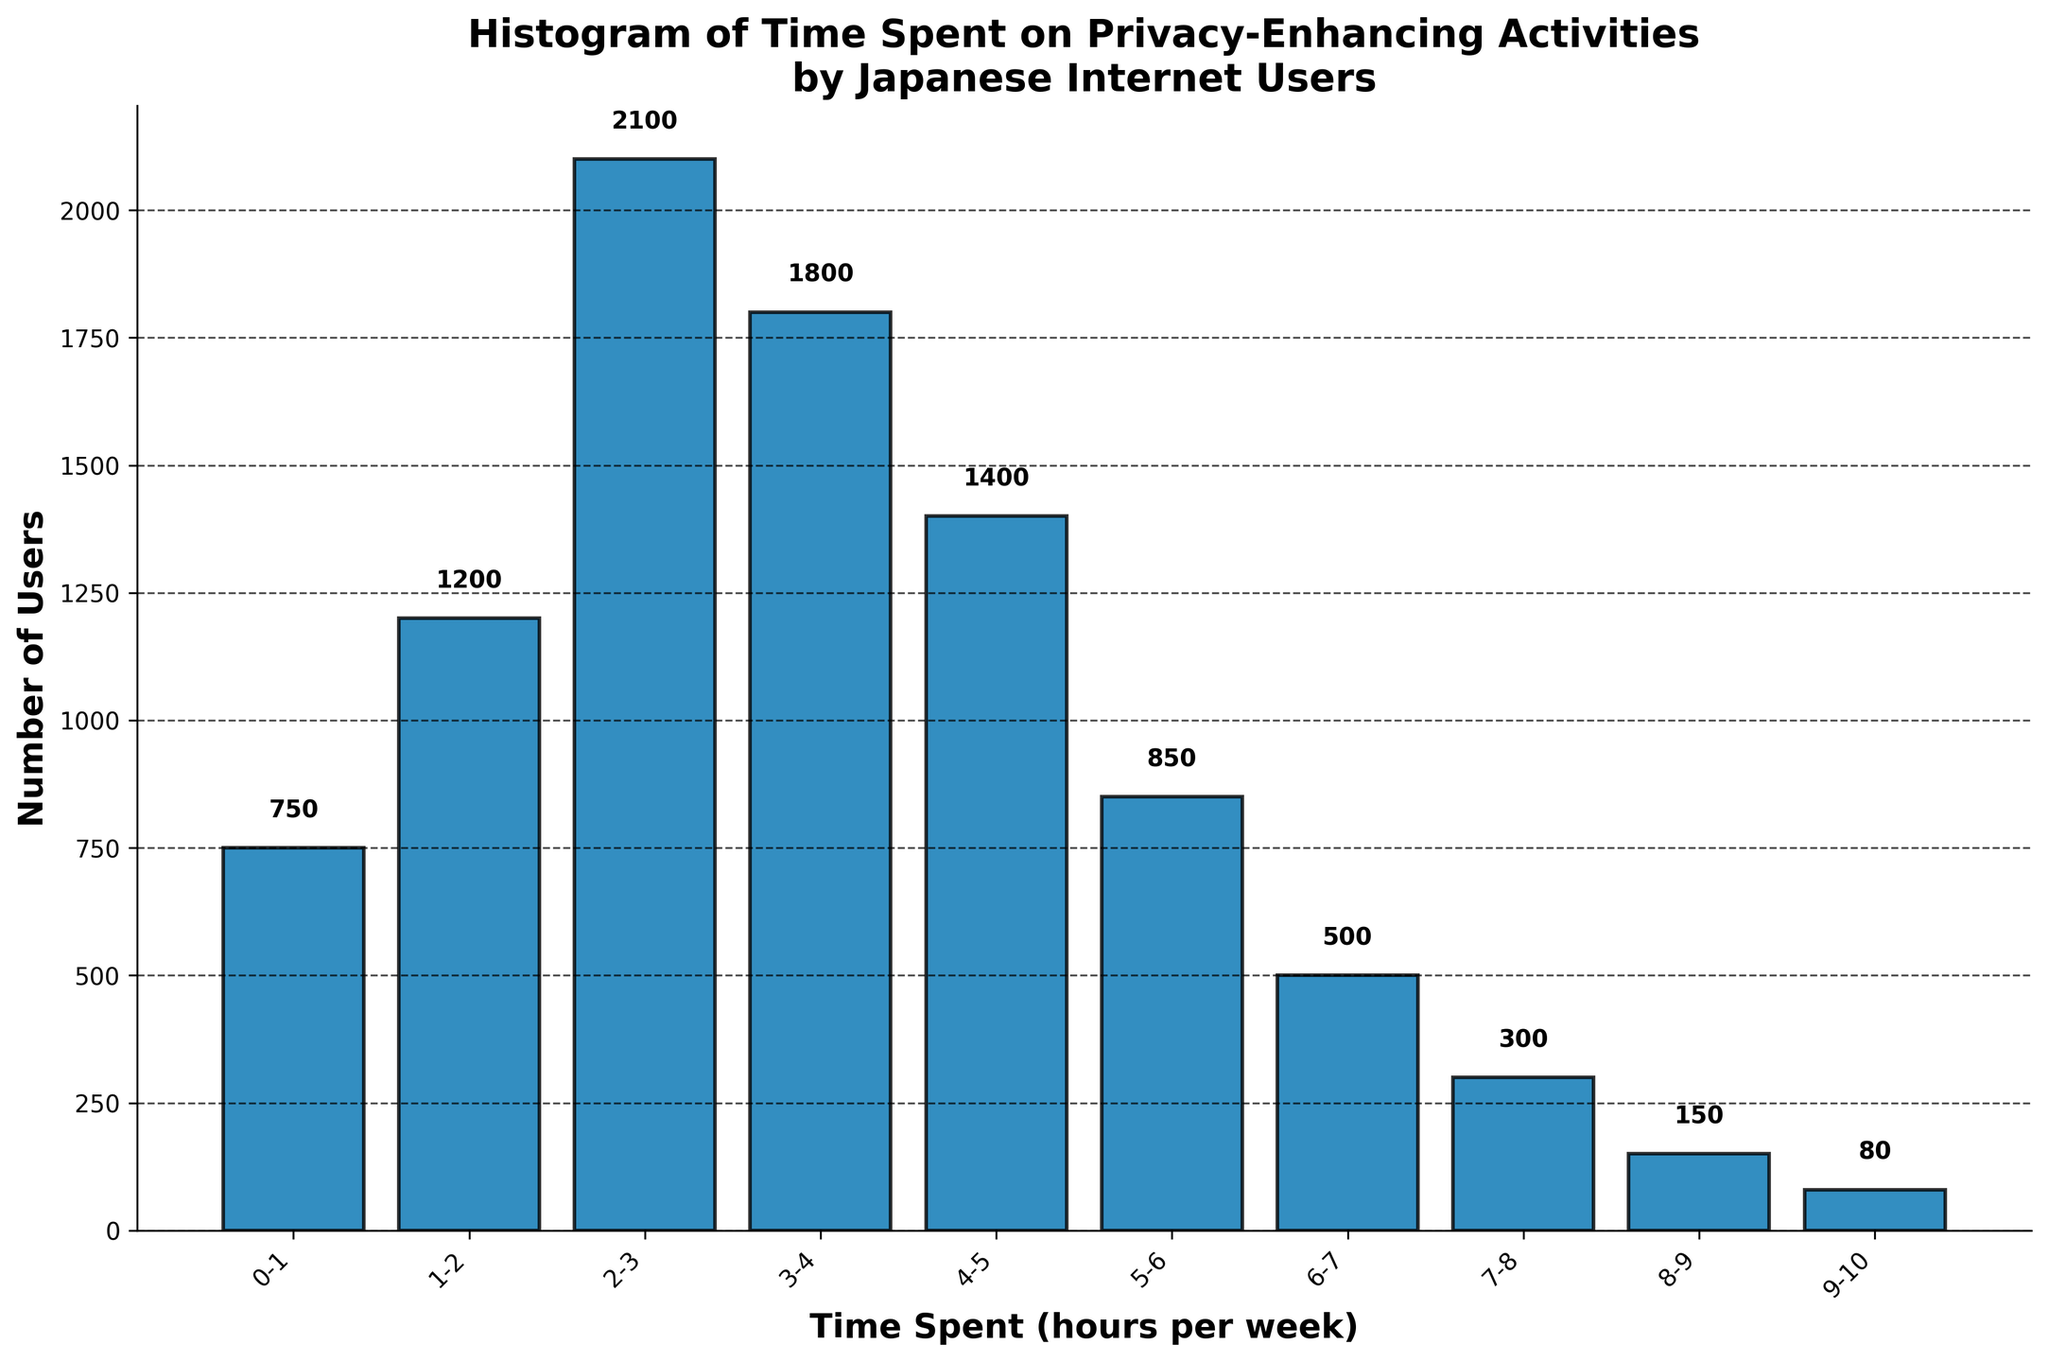What is the title of the figure? The title is usually on top of the figure and gives a brief description of the data being presented. In this case, it is about a histogram of time spent by Japanese internet users on privacy-enhancing activities.
Answer: Histogram of Time Spent on Privacy-Enhancing Activities by Japanese Internet Users How many users spent between 2-3 hours per week on privacy-enhancing activities? Find the bar corresponding to the interval of 2-3 hours per week and look at its height or the value marked above the bar.
Answer: 2100 What is the value of the tallest bar in the histogram? Identify the tallest bar and read the number of users indicated above it, which represents the highest frequency.
Answer: 2100 What is the total number of users represented in the histogram? Add up all the values from the individual bars to find the total number of users.
Answer: 9130 Which time interval has the least number of users? Locate the shortest bar and read the corresponding time interval on the x-axis.
Answer: 9-10 hours per week How many more users spend 3-4 hours compared to 8-9 hours on privacy-enhancing activities? Subtract the number of users in the 8-9 hours interval from those in the 3-4 hours interval.
Answer: 1650 Which two time intervals have the closest number of users? Compare the values of adjacent bars to find the pair with the smallest difference.
Answer: 0-1 and 7-8 hours per week On average, how many users spend between 5 and 7 hours? Add the number of users who spend between 5-6 and 6-7 hours together and divide by 2.
Answer: 675 What is the median value of the number of users across all time intervals? List all the values in ascending order and find the middle value. If there is an even number of values, calculate the average of the two middle numbers. Here the middle values are 1200 and 1400, and their average is 1300.
Answer: 1300 Is the number of users spending 4-5 hours more or less than twice the number of users spending 0-1 hours? Calculate twice the number of users in the 0-1 hours interval and compare it with the users in the 4-5 hours interval.
Answer: More 